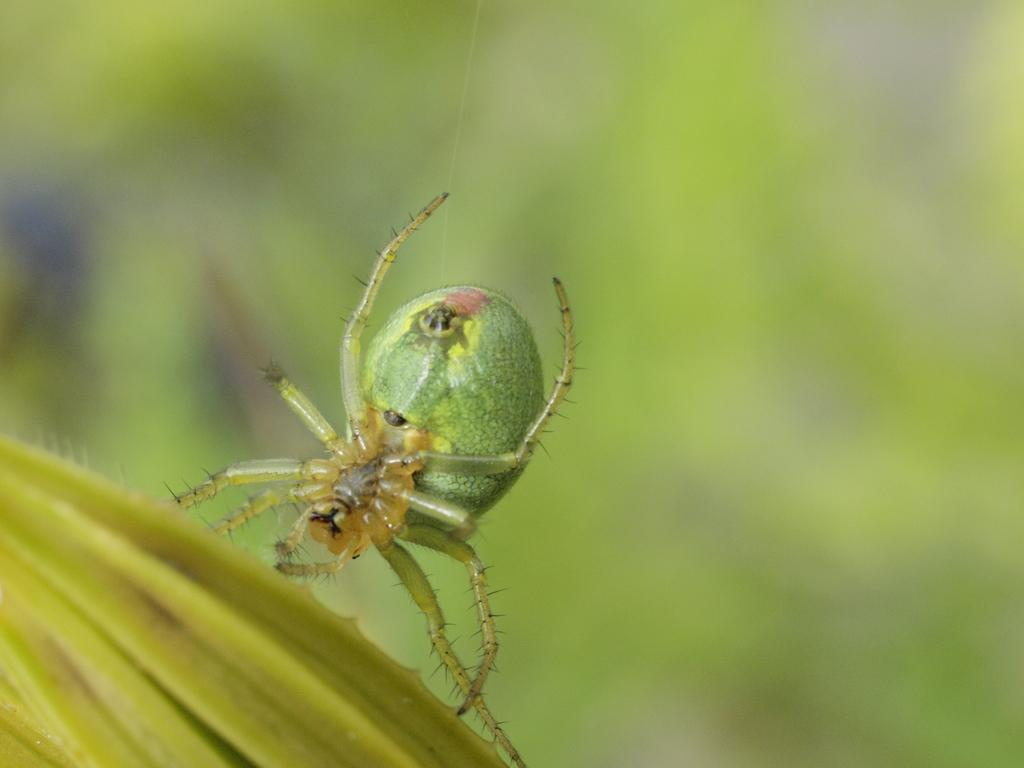What is the main subject of the image? The main subject of the image is a spider. What is the spider situated on? The spider is on a lemon yellow thing. Can you describe the background of the image? The background of the image is blurred. What type of distribution is being used to apply oil on the canvas in the image? There is no canvas, oil, or distribution present in the image; it features a spider on a lemon yellow thing. 